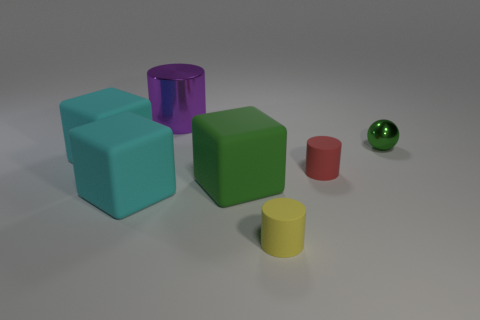Subtract all green cubes. Subtract all gray spheres. How many cubes are left? 2 Add 3 small green shiny cylinders. How many objects exist? 10 Subtract all balls. How many objects are left? 6 Subtract 0 red blocks. How many objects are left? 7 Subtract all spheres. Subtract all cyan shiny balls. How many objects are left? 6 Add 3 big purple cylinders. How many big purple cylinders are left? 4 Add 2 small green things. How many small green things exist? 3 